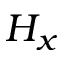<formula> <loc_0><loc_0><loc_500><loc_500>H _ { x }</formula> 